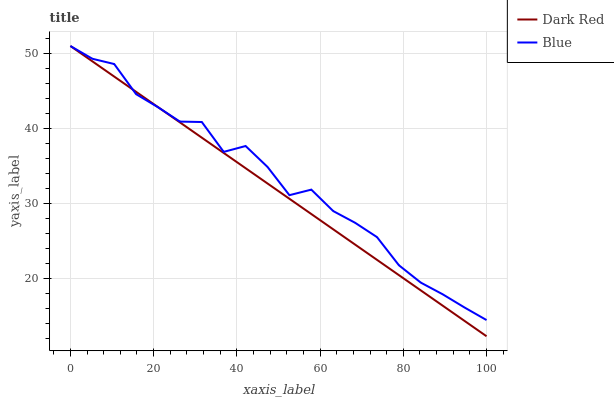Does Dark Red have the minimum area under the curve?
Answer yes or no. Yes. Does Blue have the maximum area under the curve?
Answer yes or no. Yes. Does Dark Red have the maximum area under the curve?
Answer yes or no. No. Is Dark Red the smoothest?
Answer yes or no. Yes. Is Blue the roughest?
Answer yes or no. Yes. Is Dark Red the roughest?
Answer yes or no. No. Does Dark Red have the lowest value?
Answer yes or no. Yes. Does Dark Red have the highest value?
Answer yes or no. Yes. Does Dark Red intersect Blue?
Answer yes or no. Yes. Is Dark Red less than Blue?
Answer yes or no. No. Is Dark Red greater than Blue?
Answer yes or no. No. 